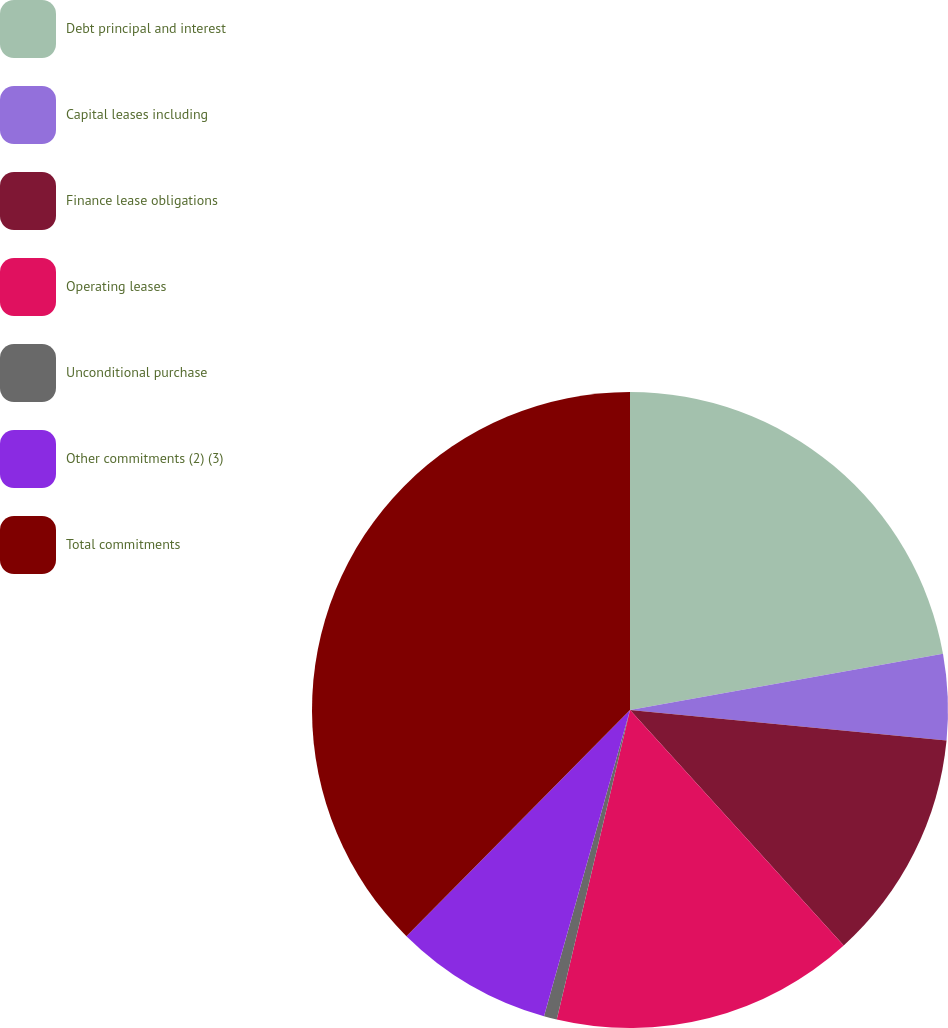Convert chart to OTSL. <chart><loc_0><loc_0><loc_500><loc_500><pie_chart><fcel>Debt principal and interest<fcel>Capital leases including<fcel>Finance lease obligations<fcel>Operating leases<fcel>Unconditional purchase<fcel>Other commitments (2) (3)<fcel>Total commitments<nl><fcel>22.17%<fcel>4.36%<fcel>11.74%<fcel>15.43%<fcel>0.66%<fcel>8.05%<fcel>37.59%<nl></chart> 